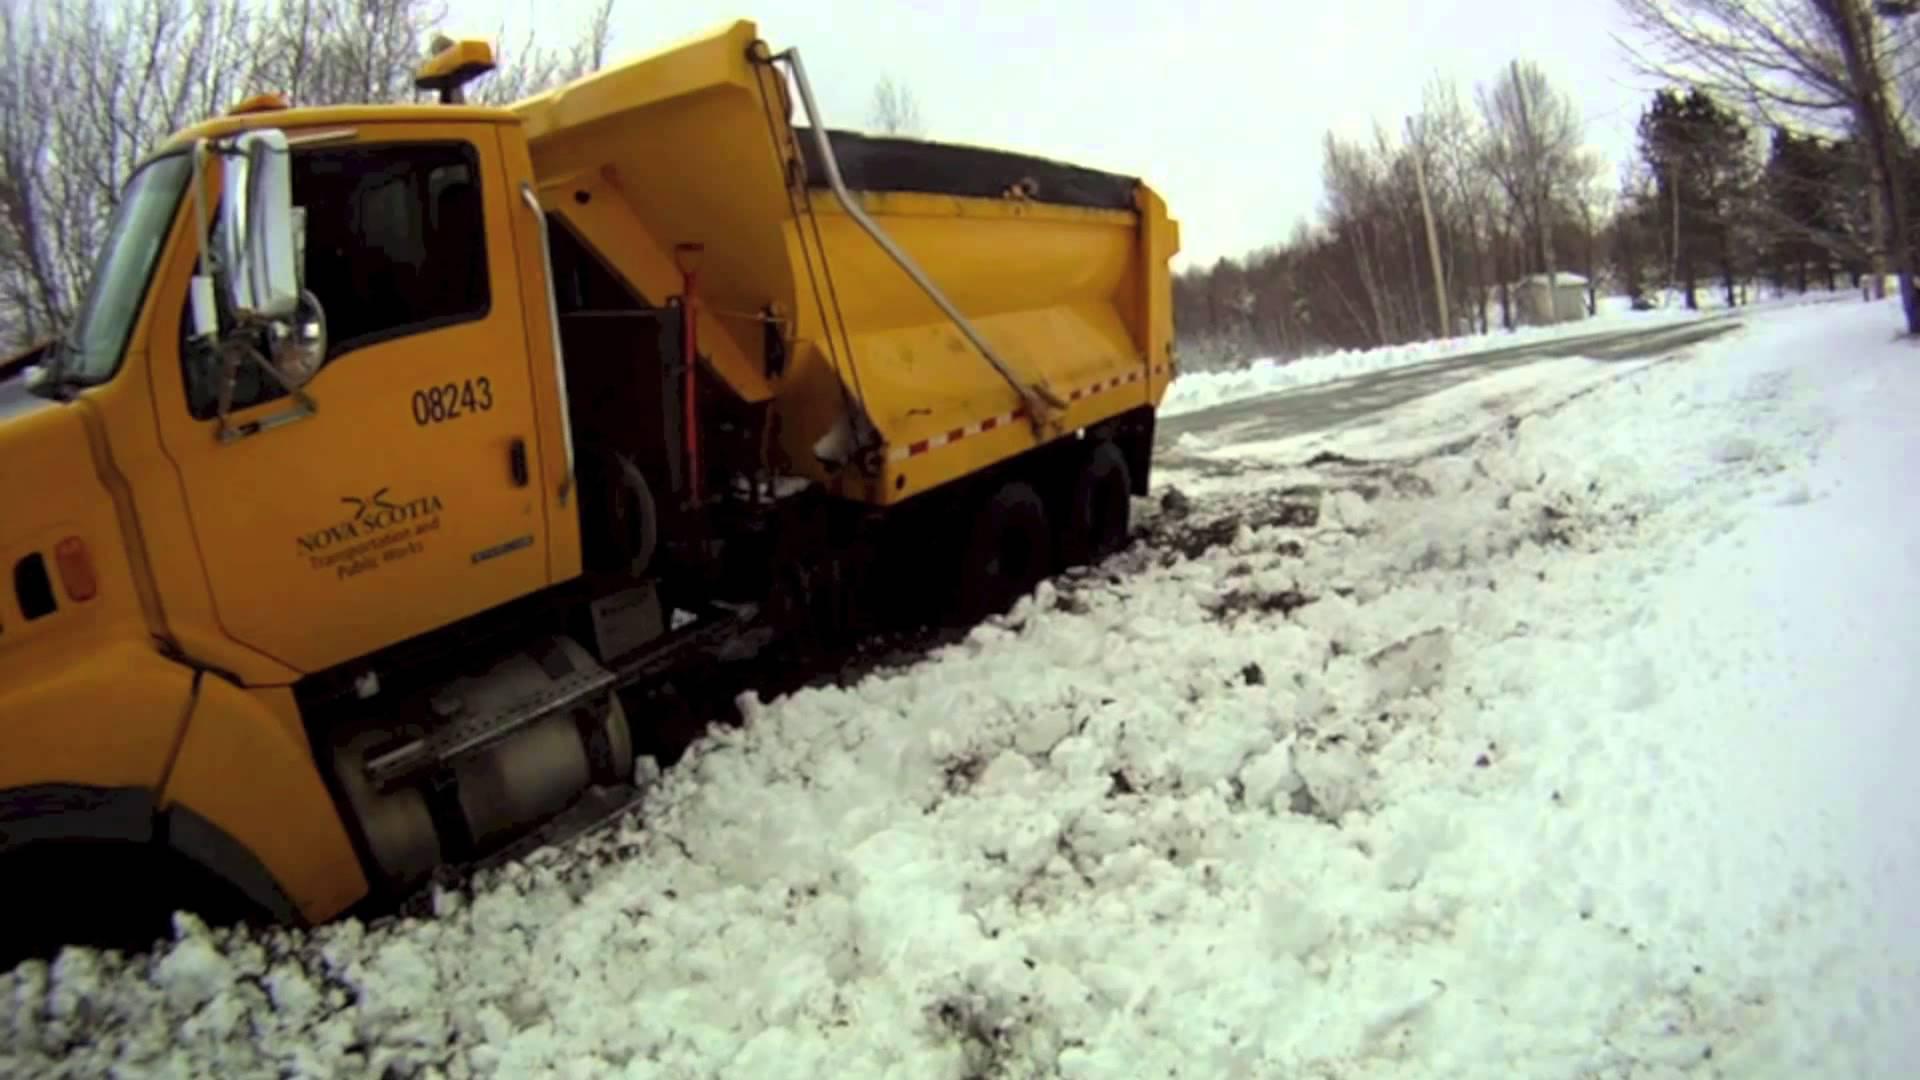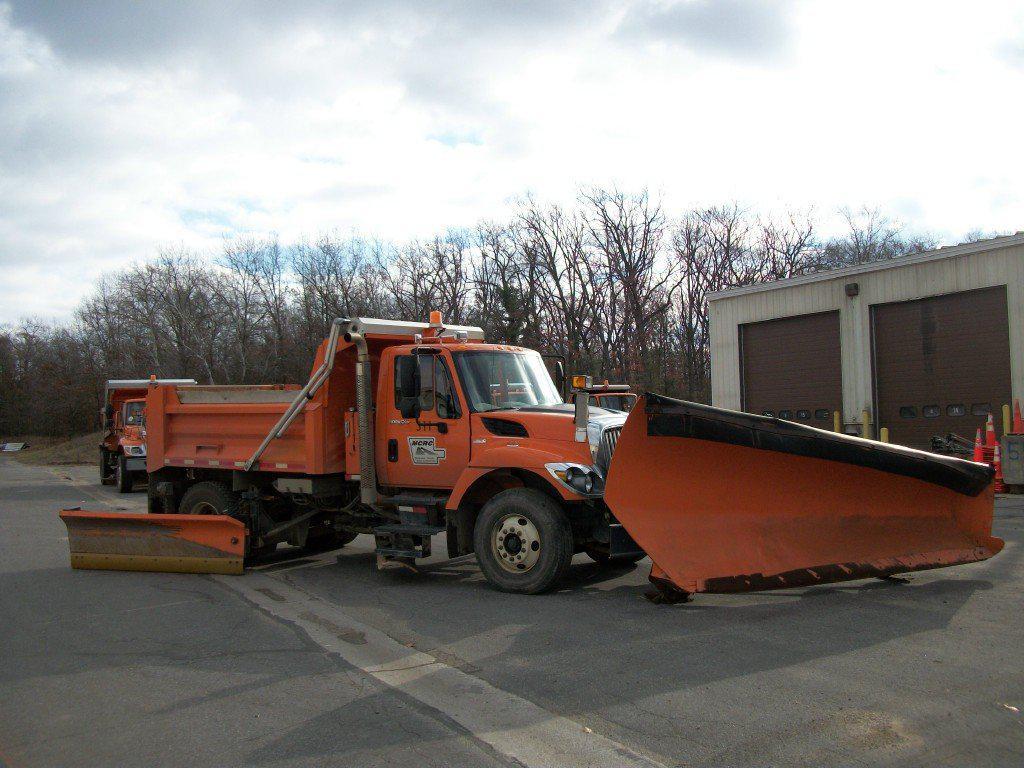The first image is the image on the left, the second image is the image on the right. For the images displayed, is the sentence "There are at most 3 trucks total." factually correct? Answer yes or no. Yes. 